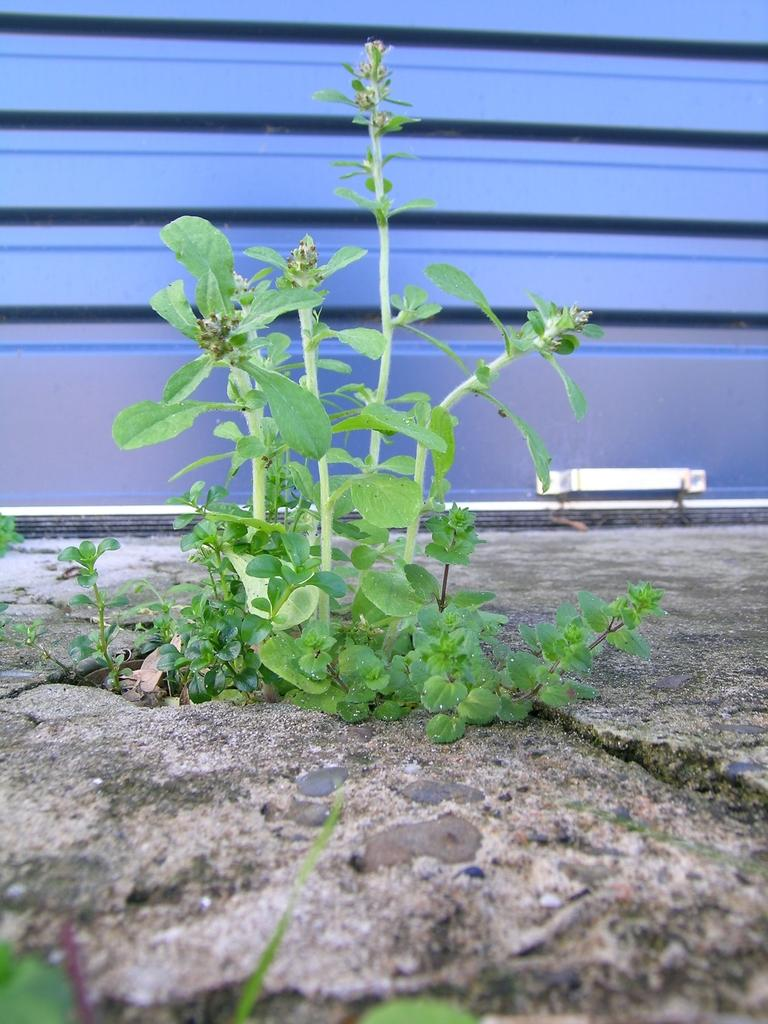What type of vegetation is present on the ground in the image? There are plants on the ground in the image. What can be seen behind the plants? There is a wall visible behind the plants. What feature is present at the bottom of the wall? There is a handle at the bottom of the wall. What type of fruit is hanging from the handle at the bottom of the wall in the image? There is no fruit hanging from the handle at the bottom of the wall in the image. 